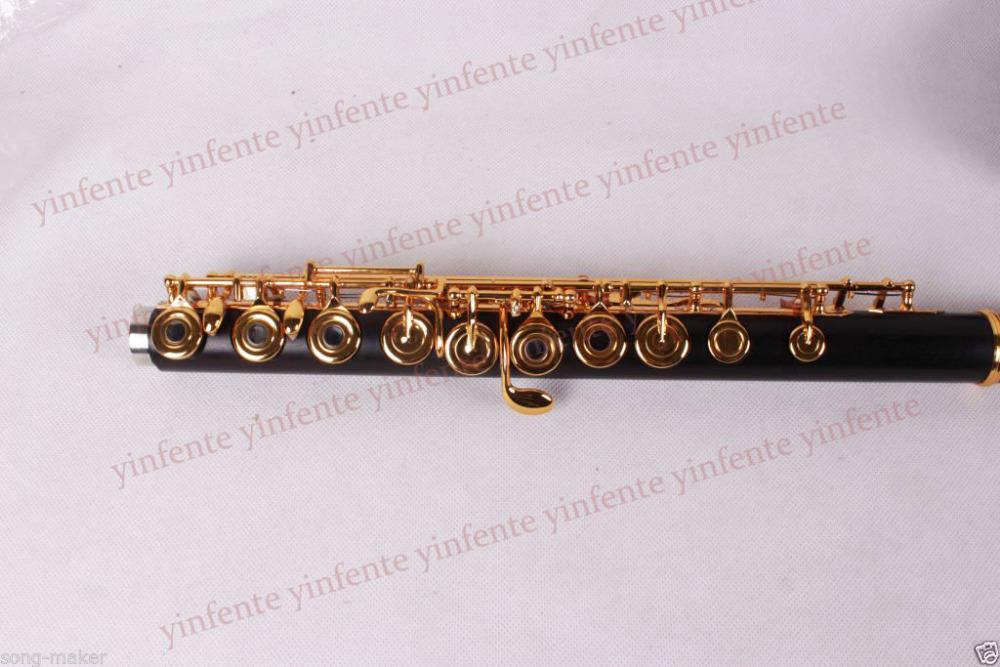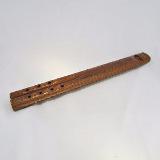The first image is the image on the left, the second image is the image on the right. Examine the images to the left and right. Is the description "The left image includes at least two black tube-shaped flute parts displayed horizontally but spaced apart." accurate? Answer yes or no. No. 